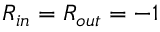<formula> <loc_0><loc_0><loc_500><loc_500>R _ { i n } = R _ { o u t } = - 1</formula> 